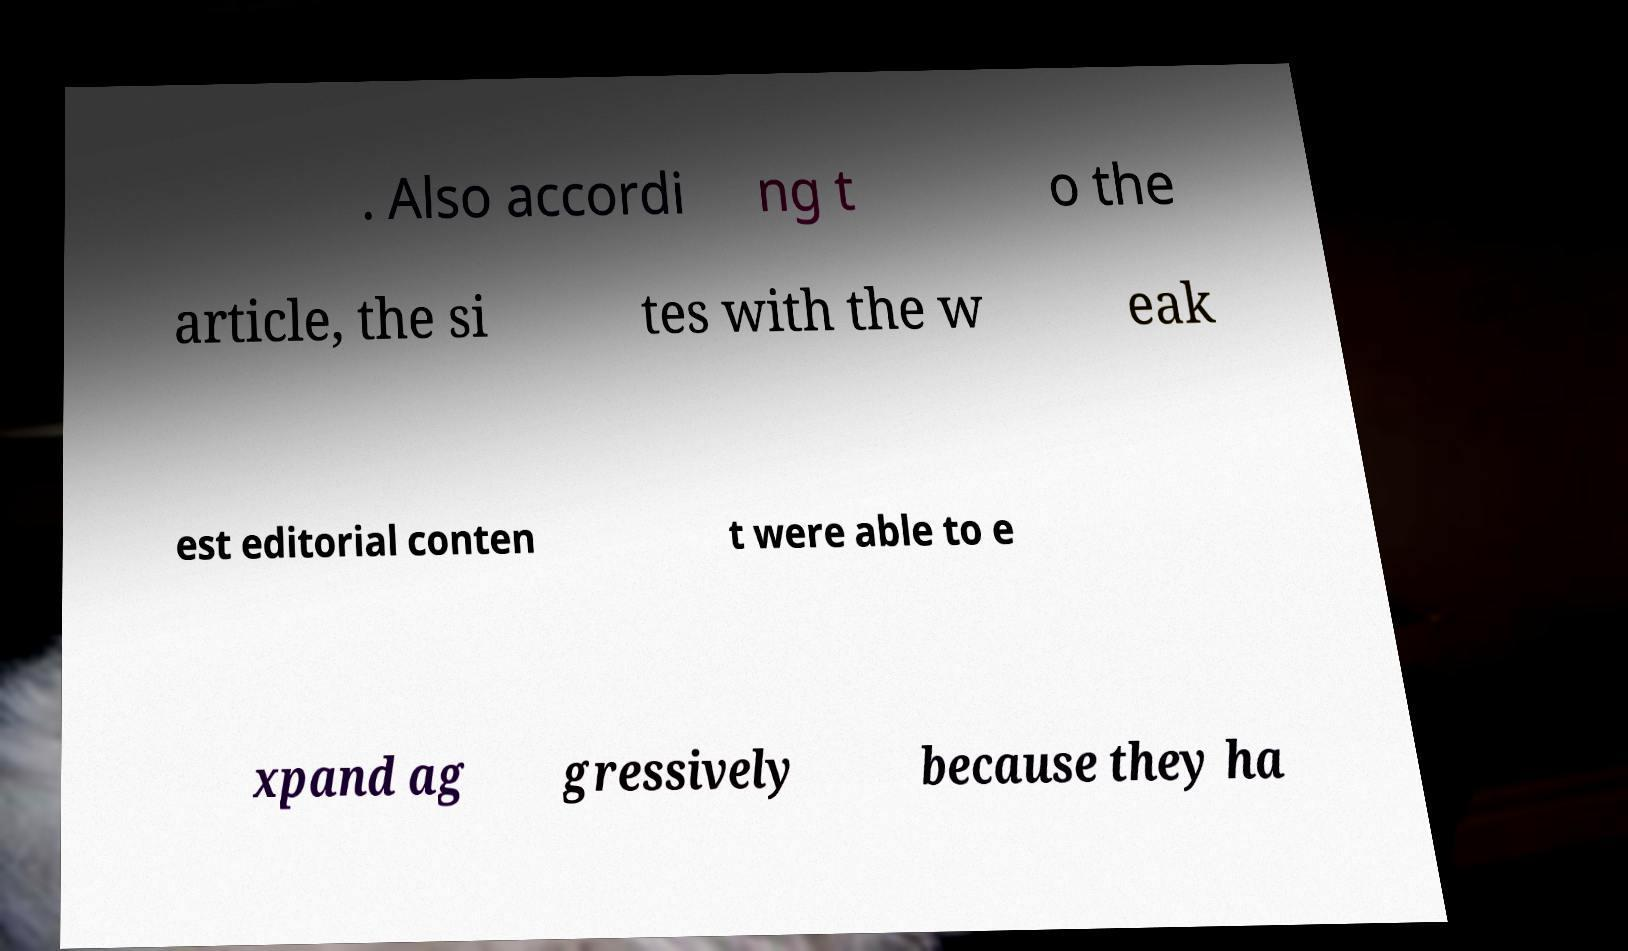For documentation purposes, I need the text within this image transcribed. Could you provide that? . Also accordi ng t o the article, the si tes with the w eak est editorial conten t were able to e xpand ag gressively because they ha 